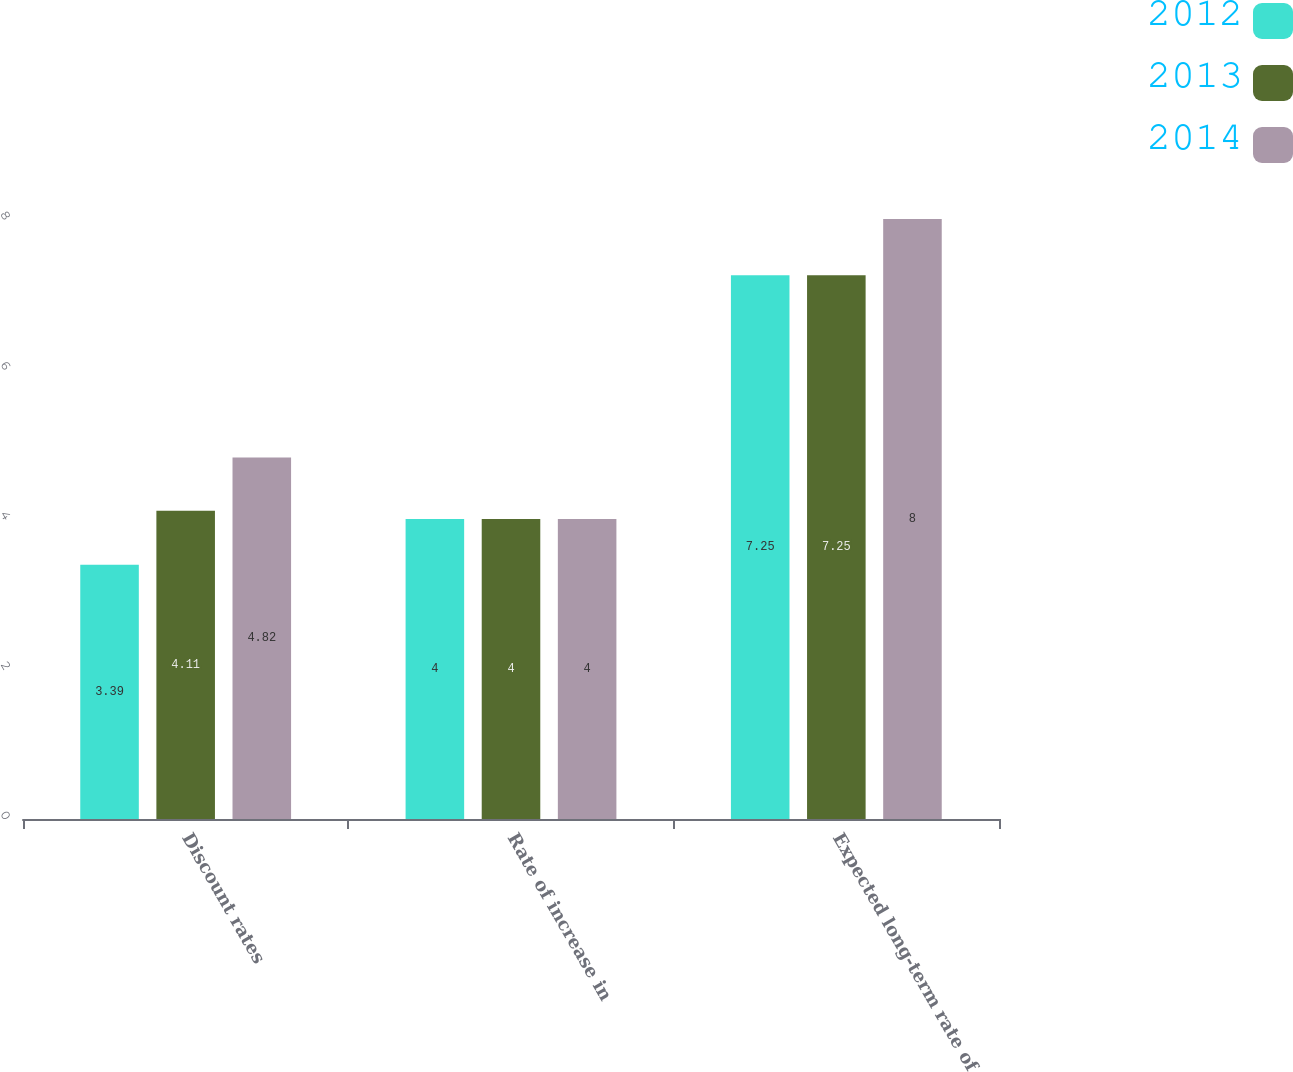Convert chart. <chart><loc_0><loc_0><loc_500><loc_500><stacked_bar_chart><ecel><fcel>Discount rates<fcel>Rate of increase in<fcel>Expected long-term rate of<nl><fcel>2012<fcel>3.39<fcel>4<fcel>7.25<nl><fcel>2013<fcel>4.11<fcel>4<fcel>7.25<nl><fcel>2014<fcel>4.82<fcel>4<fcel>8<nl></chart> 